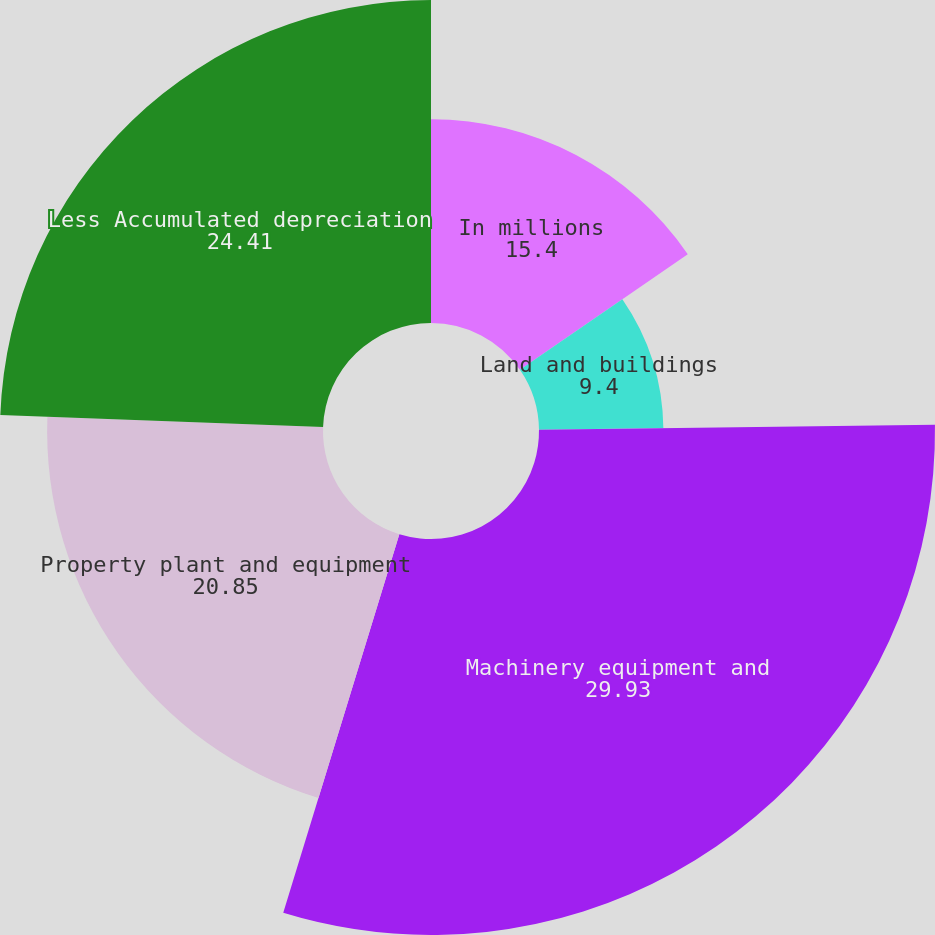<chart> <loc_0><loc_0><loc_500><loc_500><pie_chart><fcel>In millions<fcel>Land and buildings<fcel>Machinery equipment and<fcel>Property plant and equipment<fcel>Less Accumulated depreciation<nl><fcel>15.4%<fcel>9.4%<fcel>29.93%<fcel>20.85%<fcel>24.41%<nl></chart> 